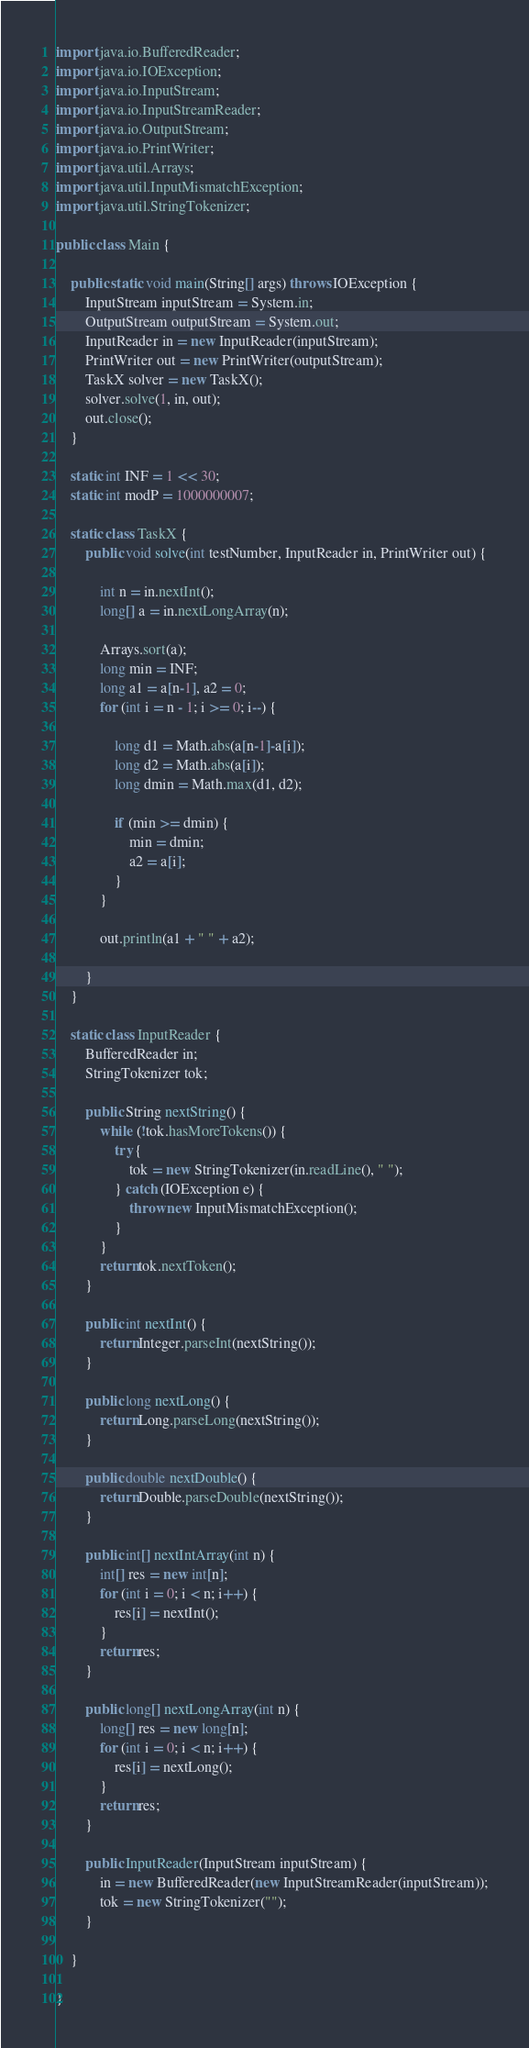<code> <loc_0><loc_0><loc_500><loc_500><_Java_>
import java.io.BufferedReader;
import java.io.IOException;
import java.io.InputStream;
import java.io.InputStreamReader;
import java.io.OutputStream;
import java.io.PrintWriter;
import java.util.Arrays;
import java.util.InputMismatchException;
import java.util.StringTokenizer;

public class Main {

	public static void main(String[] args) throws IOException {
		InputStream inputStream = System.in;
		OutputStream outputStream = System.out;
		InputReader in = new InputReader(inputStream);
		PrintWriter out = new PrintWriter(outputStream);
		TaskX solver = new TaskX();
		solver.solve(1, in, out);
		out.close();
	}

	static int INF = 1 << 30;
	static int modP = 1000000007;

	static class TaskX {
		public void solve(int testNumber, InputReader in, PrintWriter out) {

			int n = in.nextInt();
			long[] a = in.nextLongArray(n);

			Arrays.sort(a);
			long min = INF;
			long a1 = a[n-1], a2 = 0;
			for (int i = n - 1; i >= 0; i--) {

				long d1 = Math.abs(a[n-1]-a[i]);
				long d2 = Math.abs(a[i]);
				long dmin = Math.max(d1, d2);

				if (min >= dmin) {
					min = dmin;
					a2 = a[i];
				}
			}

			out.println(a1 + " " + a2);

		}
	}

	static class InputReader {
		BufferedReader in;
		StringTokenizer tok;

		public String nextString() {
			while (!tok.hasMoreTokens()) {
				try {
					tok = new StringTokenizer(in.readLine(), " ");
				} catch (IOException e) {
					throw new InputMismatchException();
				}
			}
			return tok.nextToken();
		}

		public int nextInt() {
			return Integer.parseInt(nextString());
		}

		public long nextLong() {
			return Long.parseLong(nextString());
		}

		public double nextDouble() {
			return Double.parseDouble(nextString());
		}

		public int[] nextIntArray(int n) {
			int[] res = new int[n];
			for (int i = 0; i < n; i++) {
				res[i] = nextInt();
			}
			return res;
		}

		public long[] nextLongArray(int n) {
			long[] res = new long[n];
			for (int i = 0; i < n; i++) {
				res[i] = nextLong();
			}
			return res;
		}

		public InputReader(InputStream inputStream) {
			in = new BufferedReader(new InputStreamReader(inputStream));
			tok = new StringTokenizer("");
		}

	}

}
</code> 